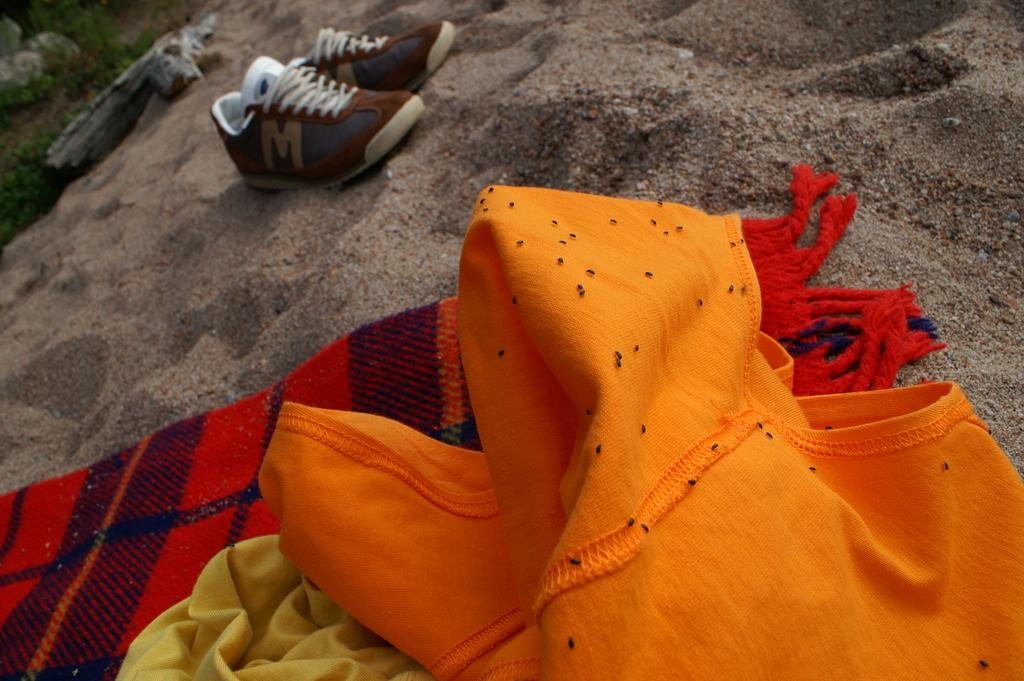What items can be seen in the image related to clothing and footwear? There are clothes and shoes in the image. Where are the clothes and shoes placed? The clothes and shoes are placed on a heap of sand. What type of natural environment is visible in the image? There is grass visible in the image. Can you tell me how many kitties are playing with the beggar in the image? There are no kitties or beggars present in the image; it only features clothes, shoes, and grass. What type of crate is visible in the image? There is no crate present in the image. 